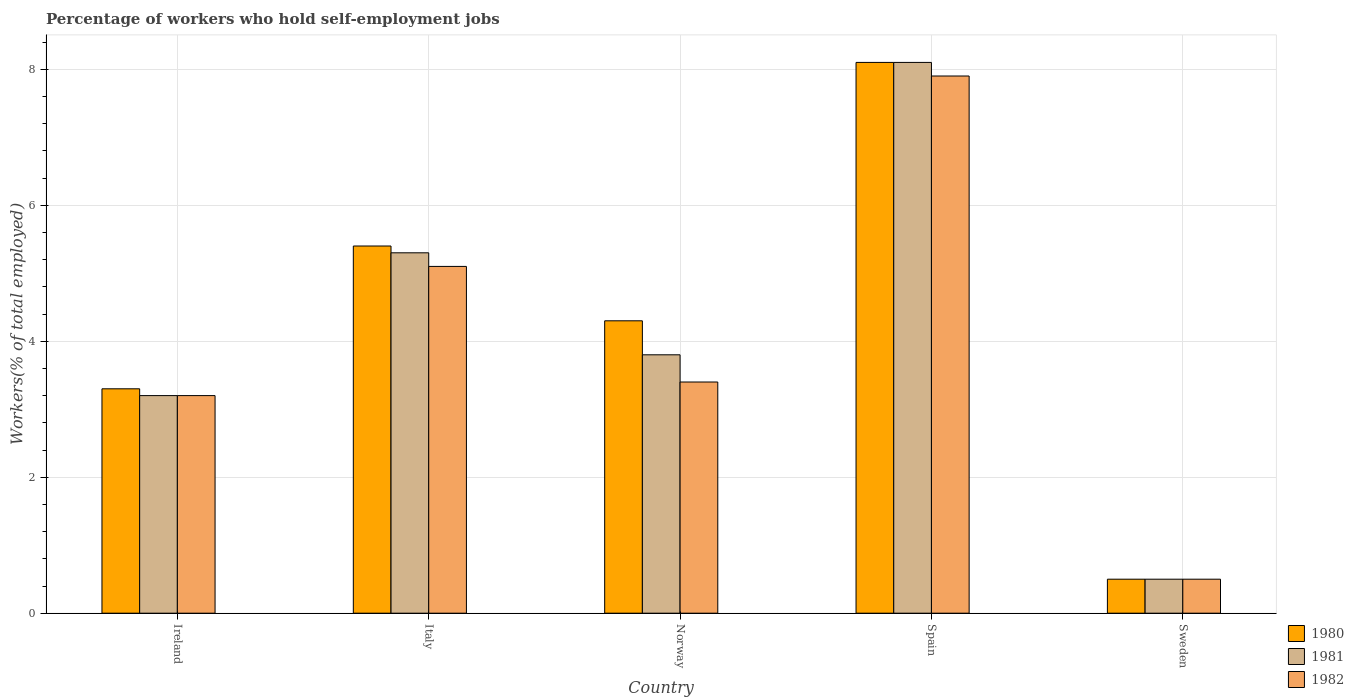How many different coloured bars are there?
Provide a short and direct response. 3. How many groups of bars are there?
Provide a short and direct response. 5. Are the number of bars per tick equal to the number of legend labels?
Your response must be concise. Yes. How many bars are there on the 2nd tick from the left?
Provide a short and direct response. 3. How many bars are there on the 2nd tick from the right?
Provide a short and direct response. 3. What is the label of the 1st group of bars from the left?
Offer a terse response. Ireland. In how many cases, is the number of bars for a given country not equal to the number of legend labels?
Ensure brevity in your answer.  0. What is the percentage of self-employed workers in 1982 in Italy?
Offer a very short reply. 5.1. Across all countries, what is the maximum percentage of self-employed workers in 1981?
Your answer should be compact. 8.1. In which country was the percentage of self-employed workers in 1982 maximum?
Provide a short and direct response. Spain. What is the total percentage of self-employed workers in 1980 in the graph?
Provide a short and direct response. 21.6. What is the difference between the percentage of self-employed workers in 1980 in Norway and that in Spain?
Ensure brevity in your answer.  -3.8. What is the difference between the percentage of self-employed workers in 1980 in Sweden and the percentage of self-employed workers in 1981 in Italy?
Keep it short and to the point. -4.8. What is the average percentage of self-employed workers in 1981 per country?
Your response must be concise. 4.18. What is the difference between the percentage of self-employed workers of/in 1980 and percentage of self-employed workers of/in 1982 in Italy?
Keep it short and to the point. 0.3. What is the ratio of the percentage of self-employed workers in 1981 in Norway to that in Spain?
Your response must be concise. 0.47. Is the percentage of self-employed workers in 1982 in Ireland less than that in Italy?
Make the answer very short. Yes. Is the difference between the percentage of self-employed workers in 1980 in Italy and Norway greater than the difference between the percentage of self-employed workers in 1982 in Italy and Norway?
Your response must be concise. No. What is the difference between the highest and the second highest percentage of self-employed workers in 1982?
Your answer should be compact. -1.7. What is the difference between the highest and the lowest percentage of self-employed workers in 1982?
Give a very brief answer. 7.4. In how many countries, is the percentage of self-employed workers in 1981 greater than the average percentage of self-employed workers in 1981 taken over all countries?
Ensure brevity in your answer.  2. Is the sum of the percentage of self-employed workers in 1980 in Ireland and Norway greater than the maximum percentage of self-employed workers in 1982 across all countries?
Offer a very short reply. No. What does the 3rd bar from the right in Norway represents?
Your response must be concise. 1980. Is it the case that in every country, the sum of the percentage of self-employed workers in 1981 and percentage of self-employed workers in 1982 is greater than the percentage of self-employed workers in 1980?
Offer a terse response. Yes. What is the difference between two consecutive major ticks on the Y-axis?
Your answer should be compact. 2. Does the graph contain grids?
Provide a succinct answer. Yes. Where does the legend appear in the graph?
Make the answer very short. Bottom right. How many legend labels are there?
Your response must be concise. 3. What is the title of the graph?
Provide a short and direct response. Percentage of workers who hold self-employment jobs. What is the label or title of the Y-axis?
Keep it short and to the point. Workers(% of total employed). What is the Workers(% of total employed) in 1980 in Ireland?
Your answer should be compact. 3.3. What is the Workers(% of total employed) in 1981 in Ireland?
Keep it short and to the point. 3.2. What is the Workers(% of total employed) of 1982 in Ireland?
Give a very brief answer. 3.2. What is the Workers(% of total employed) in 1980 in Italy?
Your response must be concise. 5.4. What is the Workers(% of total employed) of 1981 in Italy?
Ensure brevity in your answer.  5.3. What is the Workers(% of total employed) of 1982 in Italy?
Your answer should be compact. 5.1. What is the Workers(% of total employed) of 1980 in Norway?
Your answer should be compact. 4.3. What is the Workers(% of total employed) of 1981 in Norway?
Provide a short and direct response. 3.8. What is the Workers(% of total employed) in 1982 in Norway?
Keep it short and to the point. 3.4. What is the Workers(% of total employed) of 1980 in Spain?
Offer a terse response. 8.1. What is the Workers(% of total employed) in 1981 in Spain?
Ensure brevity in your answer.  8.1. What is the Workers(% of total employed) of 1982 in Spain?
Provide a short and direct response. 7.9. Across all countries, what is the maximum Workers(% of total employed) in 1980?
Ensure brevity in your answer.  8.1. Across all countries, what is the maximum Workers(% of total employed) of 1981?
Keep it short and to the point. 8.1. Across all countries, what is the maximum Workers(% of total employed) of 1982?
Ensure brevity in your answer.  7.9. Across all countries, what is the minimum Workers(% of total employed) in 1980?
Provide a short and direct response. 0.5. Across all countries, what is the minimum Workers(% of total employed) of 1981?
Keep it short and to the point. 0.5. What is the total Workers(% of total employed) of 1980 in the graph?
Your answer should be compact. 21.6. What is the total Workers(% of total employed) of 1981 in the graph?
Make the answer very short. 20.9. What is the total Workers(% of total employed) in 1982 in the graph?
Offer a very short reply. 20.1. What is the difference between the Workers(% of total employed) of 1980 in Ireland and that in Norway?
Give a very brief answer. -1. What is the difference between the Workers(% of total employed) in 1981 in Ireland and that in Norway?
Offer a very short reply. -0.6. What is the difference between the Workers(% of total employed) in 1980 in Ireland and that in Spain?
Offer a terse response. -4.8. What is the difference between the Workers(% of total employed) in 1981 in Ireland and that in Spain?
Make the answer very short. -4.9. What is the difference between the Workers(% of total employed) of 1982 in Ireland and that in Spain?
Keep it short and to the point. -4.7. What is the difference between the Workers(% of total employed) in 1981 in Ireland and that in Sweden?
Provide a succinct answer. 2.7. What is the difference between the Workers(% of total employed) of 1982 in Ireland and that in Sweden?
Offer a very short reply. 2.7. What is the difference between the Workers(% of total employed) in 1980 in Italy and that in Norway?
Your response must be concise. 1.1. What is the difference between the Workers(% of total employed) in 1981 in Italy and that in Norway?
Offer a terse response. 1.5. What is the difference between the Workers(% of total employed) in 1980 in Italy and that in Spain?
Offer a very short reply. -2.7. What is the difference between the Workers(% of total employed) in 1981 in Italy and that in Spain?
Your answer should be compact. -2.8. What is the difference between the Workers(% of total employed) of 1980 in Italy and that in Sweden?
Your answer should be compact. 4.9. What is the difference between the Workers(% of total employed) in 1981 in Italy and that in Sweden?
Give a very brief answer. 4.8. What is the difference between the Workers(% of total employed) in 1982 in Italy and that in Sweden?
Give a very brief answer. 4.6. What is the difference between the Workers(% of total employed) in 1980 in Norway and that in Spain?
Offer a very short reply. -3.8. What is the difference between the Workers(% of total employed) in 1981 in Norway and that in Spain?
Your answer should be very brief. -4.3. What is the difference between the Workers(% of total employed) of 1982 in Norway and that in Spain?
Provide a succinct answer. -4.5. What is the difference between the Workers(% of total employed) in 1980 in Norway and that in Sweden?
Make the answer very short. 3.8. What is the difference between the Workers(% of total employed) in 1981 in Norway and that in Sweden?
Give a very brief answer. 3.3. What is the difference between the Workers(% of total employed) of 1981 in Spain and that in Sweden?
Give a very brief answer. 7.6. What is the difference between the Workers(% of total employed) in 1980 in Ireland and the Workers(% of total employed) in 1981 in Norway?
Your answer should be very brief. -0.5. What is the difference between the Workers(% of total employed) in 1980 in Ireland and the Workers(% of total employed) in 1982 in Norway?
Provide a succinct answer. -0.1. What is the difference between the Workers(% of total employed) of 1981 in Ireland and the Workers(% of total employed) of 1982 in Norway?
Provide a short and direct response. -0.2. What is the difference between the Workers(% of total employed) of 1981 in Ireland and the Workers(% of total employed) of 1982 in Spain?
Your answer should be compact. -4.7. What is the difference between the Workers(% of total employed) of 1980 in Ireland and the Workers(% of total employed) of 1981 in Sweden?
Ensure brevity in your answer.  2.8. What is the difference between the Workers(% of total employed) in 1981 in Ireland and the Workers(% of total employed) in 1982 in Sweden?
Offer a very short reply. 2.7. What is the difference between the Workers(% of total employed) of 1981 in Italy and the Workers(% of total employed) of 1982 in Norway?
Offer a terse response. 1.9. What is the difference between the Workers(% of total employed) in 1980 in Italy and the Workers(% of total employed) in 1982 in Spain?
Your answer should be compact. -2.5. What is the difference between the Workers(% of total employed) of 1981 in Italy and the Workers(% of total employed) of 1982 in Spain?
Provide a succinct answer. -2.6. What is the difference between the Workers(% of total employed) of 1980 in Italy and the Workers(% of total employed) of 1981 in Sweden?
Your answer should be very brief. 4.9. What is the difference between the Workers(% of total employed) in 1981 in Italy and the Workers(% of total employed) in 1982 in Sweden?
Ensure brevity in your answer.  4.8. What is the difference between the Workers(% of total employed) of 1980 in Norway and the Workers(% of total employed) of 1982 in Spain?
Your response must be concise. -3.6. What is the difference between the Workers(% of total employed) in 1980 in Norway and the Workers(% of total employed) in 1981 in Sweden?
Ensure brevity in your answer.  3.8. What is the difference between the Workers(% of total employed) in 1981 in Norway and the Workers(% of total employed) in 1982 in Sweden?
Keep it short and to the point. 3.3. What is the average Workers(% of total employed) in 1980 per country?
Ensure brevity in your answer.  4.32. What is the average Workers(% of total employed) of 1981 per country?
Your answer should be compact. 4.18. What is the average Workers(% of total employed) in 1982 per country?
Your answer should be very brief. 4.02. What is the difference between the Workers(% of total employed) of 1980 and Workers(% of total employed) of 1982 in Ireland?
Offer a terse response. 0.1. What is the difference between the Workers(% of total employed) of 1981 and Workers(% of total employed) of 1982 in Ireland?
Your response must be concise. 0. What is the difference between the Workers(% of total employed) in 1981 and Workers(% of total employed) in 1982 in Norway?
Provide a succinct answer. 0.4. What is the difference between the Workers(% of total employed) of 1980 and Workers(% of total employed) of 1982 in Spain?
Your response must be concise. 0.2. What is the difference between the Workers(% of total employed) in 1981 and Workers(% of total employed) in 1982 in Spain?
Offer a very short reply. 0.2. What is the ratio of the Workers(% of total employed) of 1980 in Ireland to that in Italy?
Your answer should be very brief. 0.61. What is the ratio of the Workers(% of total employed) in 1981 in Ireland to that in Italy?
Offer a terse response. 0.6. What is the ratio of the Workers(% of total employed) of 1982 in Ireland to that in Italy?
Offer a terse response. 0.63. What is the ratio of the Workers(% of total employed) of 1980 in Ireland to that in Norway?
Provide a short and direct response. 0.77. What is the ratio of the Workers(% of total employed) of 1981 in Ireland to that in Norway?
Your answer should be compact. 0.84. What is the ratio of the Workers(% of total employed) in 1980 in Ireland to that in Spain?
Keep it short and to the point. 0.41. What is the ratio of the Workers(% of total employed) of 1981 in Ireland to that in Spain?
Your answer should be compact. 0.4. What is the ratio of the Workers(% of total employed) in 1982 in Ireland to that in Spain?
Offer a very short reply. 0.41. What is the ratio of the Workers(% of total employed) in 1980 in Ireland to that in Sweden?
Provide a short and direct response. 6.6. What is the ratio of the Workers(% of total employed) of 1980 in Italy to that in Norway?
Provide a short and direct response. 1.26. What is the ratio of the Workers(% of total employed) in 1981 in Italy to that in Norway?
Your response must be concise. 1.39. What is the ratio of the Workers(% of total employed) of 1980 in Italy to that in Spain?
Offer a very short reply. 0.67. What is the ratio of the Workers(% of total employed) in 1981 in Italy to that in Spain?
Offer a terse response. 0.65. What is the ratio of the Workers(% of total employed) in 1982 in Italy to that in Spain?
Offer a terse response. 0.65. What is the ratio of the Workers(% of total employed) in 1980 in Italy to that in Sweden?
Keep it short and to the point. 10.8. What is the ratio of the Workers(% of total employed) in 1980 in Norway to that in Spain?
Ensure brevity in your answer.  0.53. What is the ratio of the Workers(% of total employed) in 1981 in Norway to that in Spain?
Offer a very short reply. 0.47. What is the ratio of the Workers(% of total employed) in 1982 in Norway to that in Spain?
Ensure brevity in your answer.  0.43. What is the ratio of the Workers(% of total employed) of 1980 in Norway to that in Sweden?
Offer a terse response. 8.6. What is the ratio of the Workers(% of total employed) in 1981 in Norway to that in Sweden?
Make the answer very short. 7.6. What is the ratio of the Workers(% of total employed) in 1982 in Norway to that in Sweden?
Your answer should be compact. 6.8. What is the ratio of the Workers(% of total employed) of 1980 in Spain to that in Sweden?
Provide a short and direct response. 16.2. What is the ratio of the Workers(% of total employed) of 1981 in Spain to that in Sweden?
Offer a very short reply. 16.2. What is the difference between the highest and the second highest Workers(% of total employed) in 1980?
Offer a very short reply. 2.7. What is the difference between the highest and the second highest Workers(% of total employed) of 1982?
Make the answer very short. 2.8. 